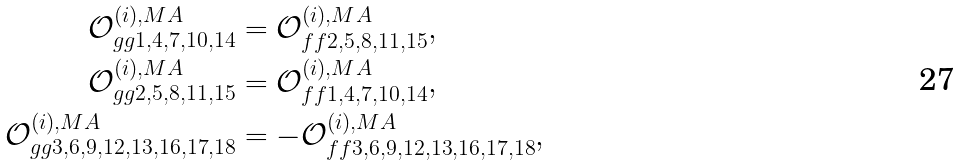<formula> <loc_0><loc_0><loc_500><loc_500>\mathcal { O } ^ { ( i ) , M A } _ { g g 1 , 4 , 7 , 1 0 , 1 4 } & = \mathcal { O } ^ { ( i ) , M A } _ { f f 2 , 5 , 8 , 1 1 , 1 5 } , \\ \mathcal { O } ^ { ( i ) , M A } _ { g g 2 , 5 , 8 , 1 1 , 1 5 } & = \mathcal { O } ^ { ( i ) , M A } _ { f f 1 , 4 , 7 , 1 0 , 1 4 } , \\ \mathcal { O } ^ { ( i ) , M A } _ { g g 3 , 6 , 9 , 1 2 , 1 3 , 1 6 , 1 7 , 1 8 } & = - \mathcal { O } ^ { ( i ) , M A } _ { f f 3 , 6 , 9 , 1 2 , 1 3 , 1 6 , 1 7 , 1 8 } ,</formula> 